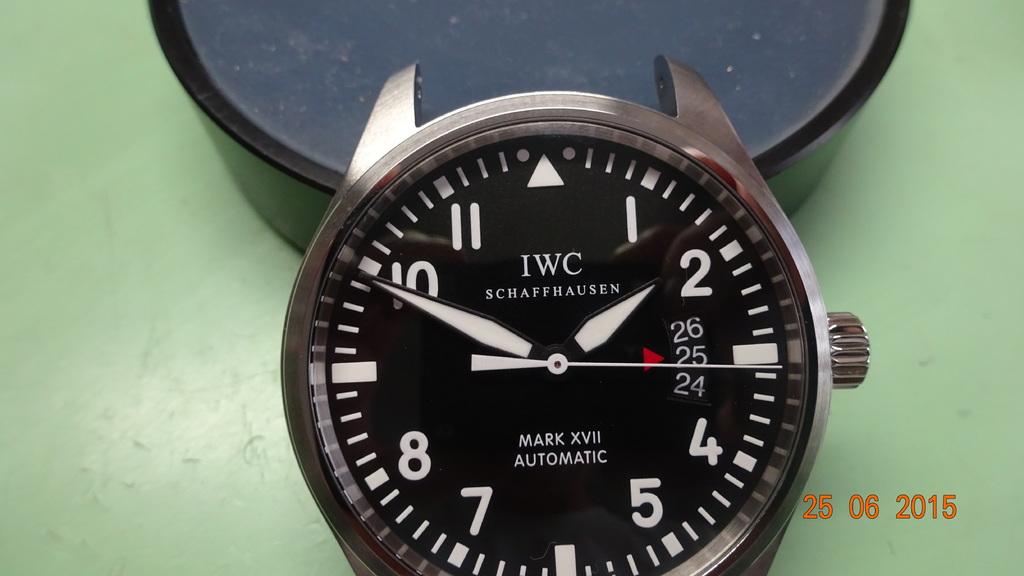What is the time on the watch?
Provide a succinct answer. 1:49. 